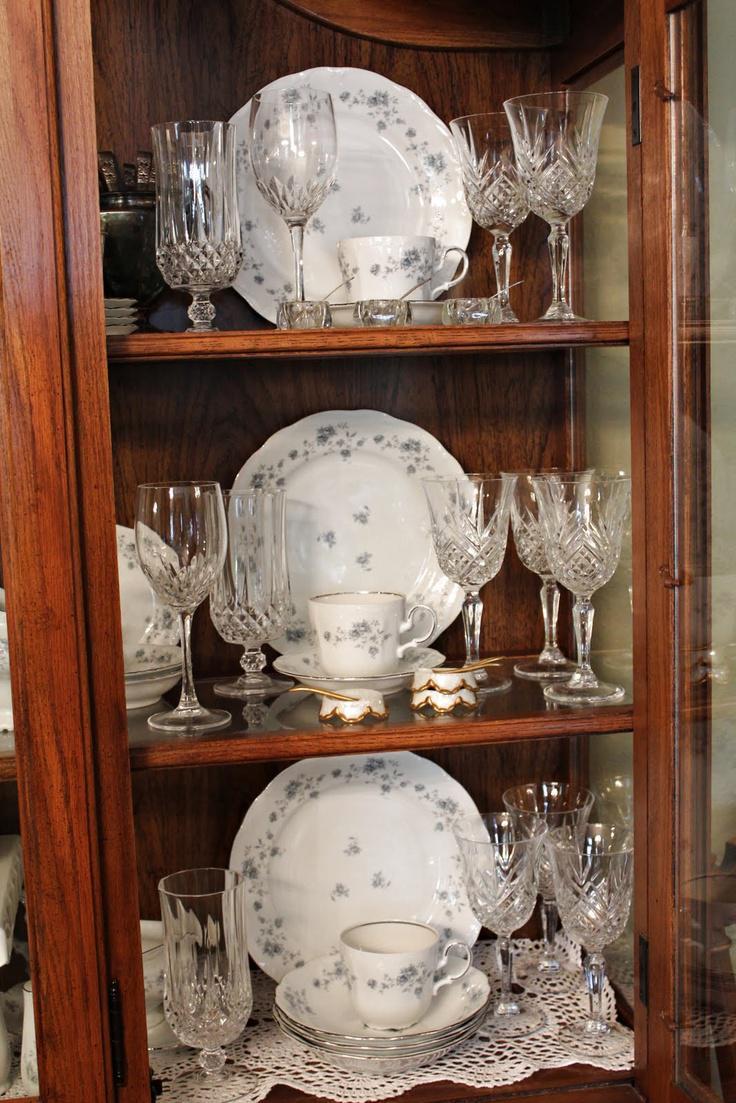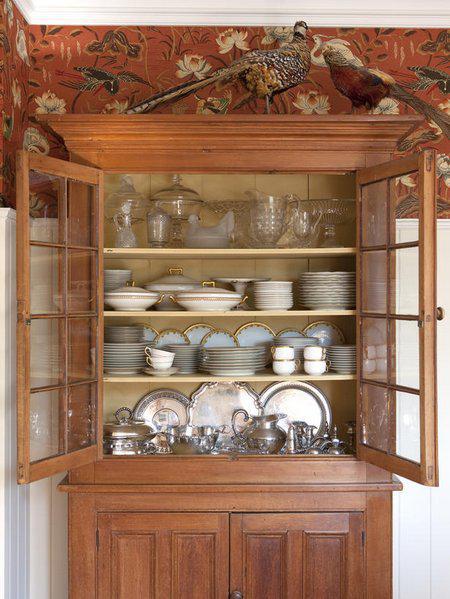The first image is the image on the left, the second image is the image on the right. Considering the images on both sides, is "One image shows a filled cabinet with at least one open paned glass door." valid? Answer yes or no. Yes. The first image is the image on the left, the second image is the image on the right. Evaluate the accuracy of this statement regarding the images: "At least two lights are seen at the top of the interior of a china cabinet.". Is it true? Answer yes or no. No. 